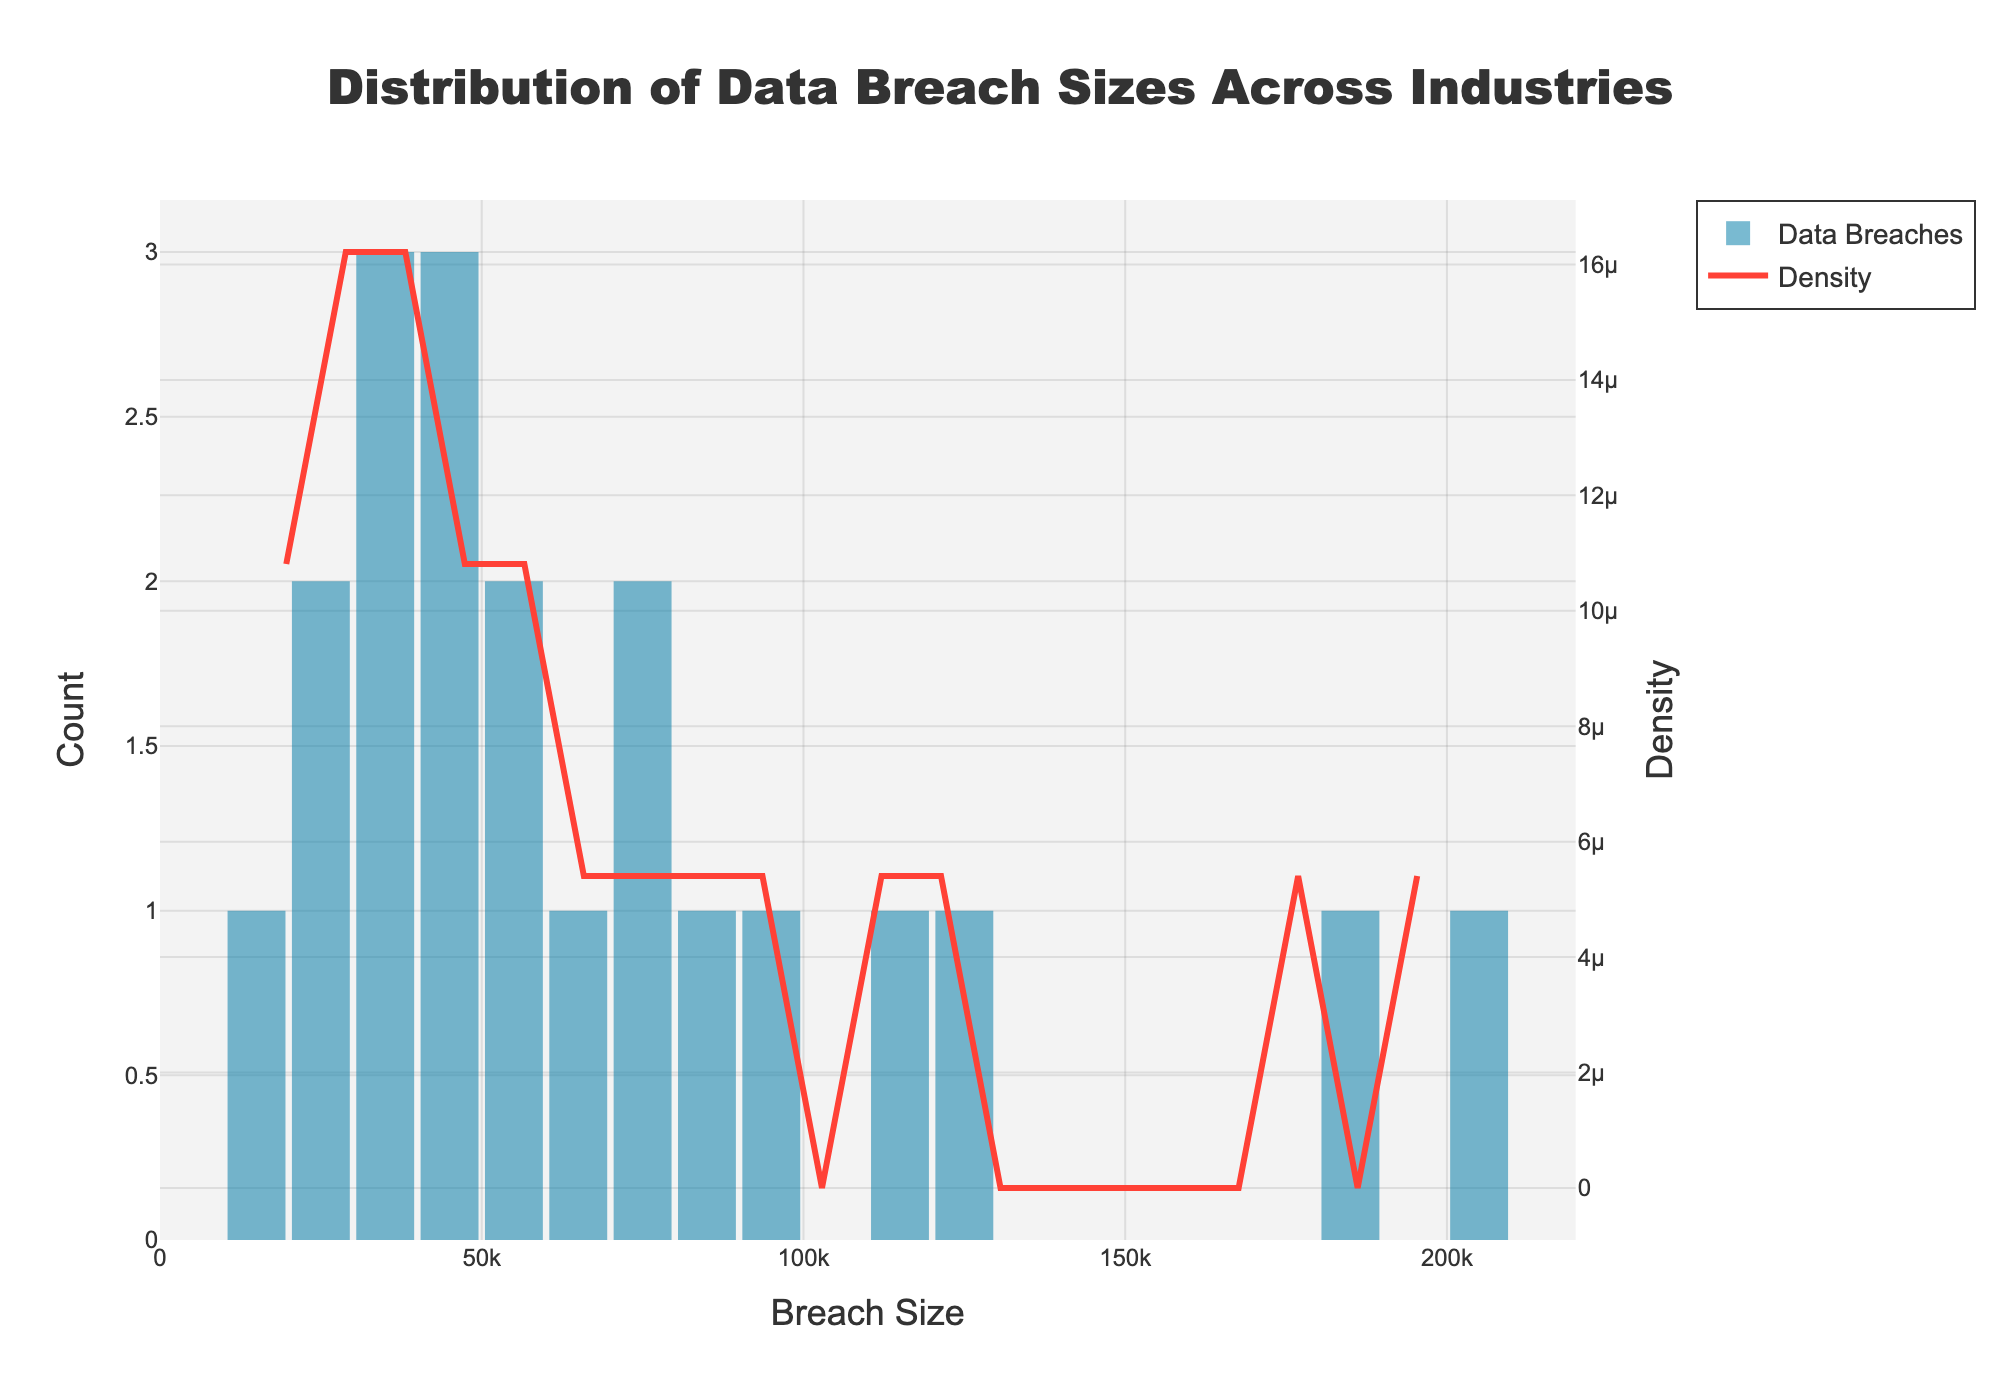What is the title of the figure? The title is located at the top center of the figure and indicates what the figure is about. It reads: "Distribution of Data Breach Sizes Across Industries".
Answer: Distribution of Data Breach Sizes Across Industries What is the range of breach sizes displayed on the x-axis? The x-axis range is from the minimum to the maximum breach size. This can be inferred by looking at the axis limits. The figure shows it ranges approximately from 0 to 220,000.
Answer: 0 to 220,000 Which industry has the largest data breach size? By examining the x-axis for the highest data point, it corresponds to the Technology sector. The bar is the furthest to the right.
Answer: Technology What does the red line in the figure represent? The red line is the KDE (Density) curve. It shows the distribution of breach sizes smoothed into a continuous probability density estimate.
Answer: KDE (Density) Curve How many bins are used in the histogram? By examining the histogram, one can count the number of distinct bars or bins in the figure. There are 20 bins in total.
Answer: 20 bins Which breach size bin has the highest frequency? Look at the height of the bars in the histogram. The bin around 20,000 breach sizes has the highest frequency as it has the tallest bar.
Answer: Around 20,000 How does the density change relative to breach size? Observe the red KDE line. Initially, the density is high for smaller breach sizes, peaks around 20,000, and then gradually decreases as breach size increases.
Answer: Decreases with increase Compare the breach size counts between Healthcare and Finance industries. Which one is larger? Find the heights of the bars corresponding to the Healthcare (50,000) and Finance (75,000) breach sizes. The Finance bar is taller than the Healthcare bar, indicating more or larger breaches.
Answer: Finance What is the approximate density value at the 100,000 breach size? Locate the point where 100,000 falls on the x-axis and check the corresponding y-value of the red KDE curve. The density value seems to be around 0.000006.
Answer: 0.000006 What does the y-axis on the secondary plot represent, and how is it different from the primary y-axis? The primary y-axis shows the count of breaches in each size bin. The secondary y-axis shows the density, scaled differently as it normalizes the data to a probability distribution.
Answer: Count vs. Density 